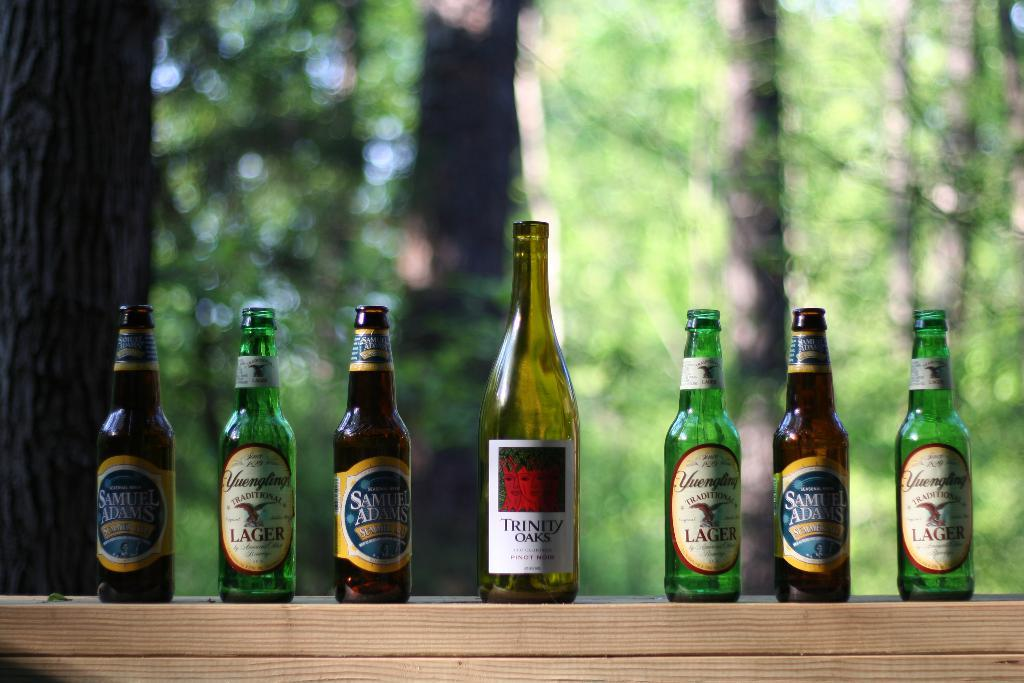<image>
Present a compact description of the photo's key features. Sona ledge with forest back ground are six bottles fro Yuengling and Sam Adams breweries with on bottle of trinity Oaks wine 